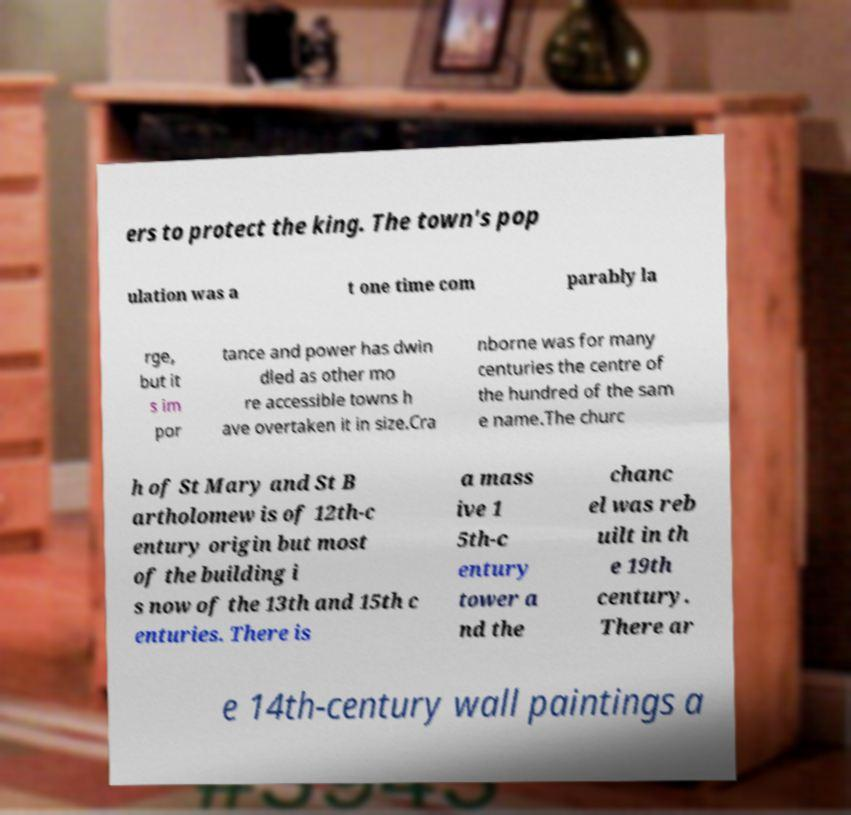There's text embedded in this image that I need extracted. Can you transcribe it verbatim? ers to protect the king. The town's pop ulation was a t one time com parably la rge, but it s im por tance and power has dwin dled as other mo re accessible towns h ave overtaken it in size.Cra nborne was for many centuries the centre of the hundred of the sam e name.The churc h of St Mary and St B artholomew is of 12th-c entury origin but most of the building i s now of the 13th and 15th c enturies. There is a mass ive 1 5th-c entury tower a nd the chanc el was reb uilt in th e 19th century. There ar e 14th-century wall paintings a 